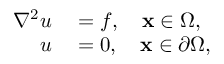Convert formula to latex. <formula><loc_0><loc_0><loc_500><loc_500>\begin{array} { r l } { \nabla ^ { 2 } u } & = f , \quad x \in \Omega , } \\ { u } & = 0 , \quad x \in \partial \Omega , } \end{array}</formula> 